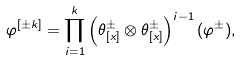<formula> <loc_0><loc_0><loc_500><loc_500>\varphi ^ { [ \pm k ] } = \prod _ { i = 1 } ^ { k } \left ( \theta ^ { \pm } _ { [ x ] } \otimes \theta ^ { \pm } _ { [ x ] } \right ) ^ { i - 1 } ( \varphi ^ { \pm } ) ,</formula> 